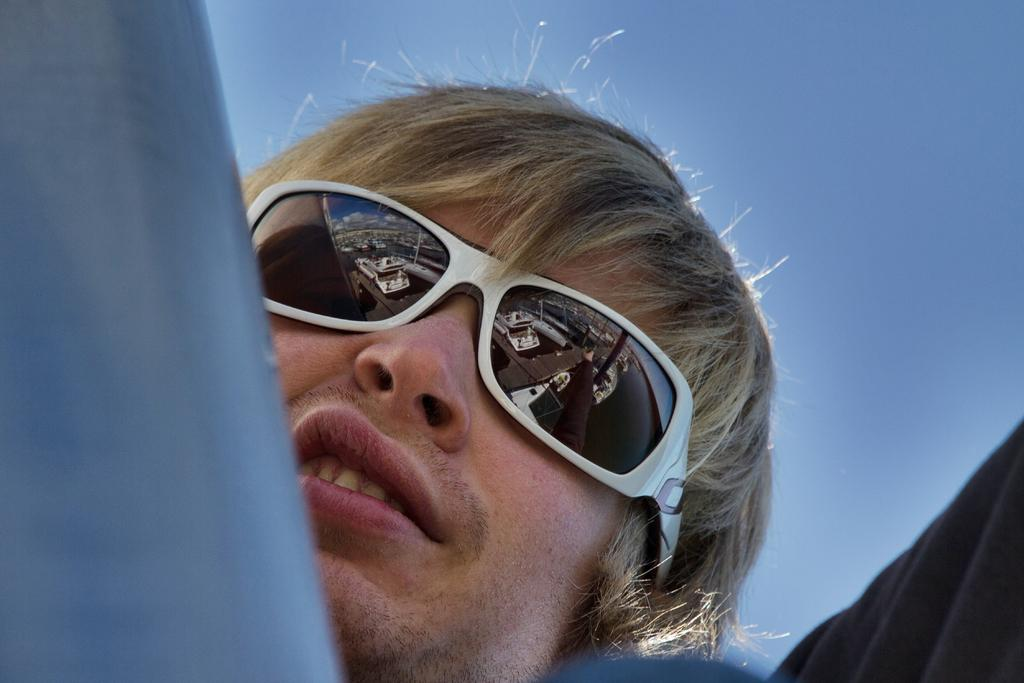What can be seen in the foreground of the image? There are objects in the foreground of the image. Can you describe the person in the image? The person is behind the objects in the image. What is visible in the background of the image? The sky is visible in the background of the image. What grade of poison is the person using in the image? There is no mention of poison or any substance being used in the image. Is there a swing visible in the image? No, there is no swing present in the image. 